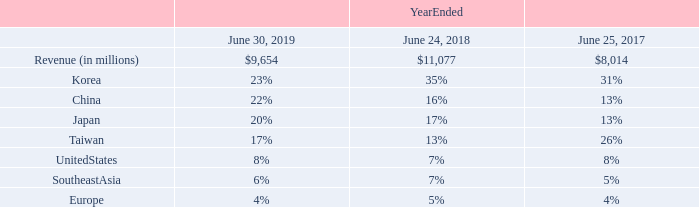Results of Operations
Revenue
Revenue decreased in fiscal year 2019 compared to fiscal year 2018, but increased compared to fiscal year 2017, primarily as a result of the volatility of semiconductor capital investments by our customers. The overall Asia region continued to account for a majority of our revenues as a substantial amount of the worldwide capacity investments for semiconductor manufacturing continued to occur in this region.
Our deferred revenue balance was $449 million as of June 30, 2019, compared to $994 million as of June 24, 2018. The deferred revenue at the end of June 2019 is recognized under Accounting Standard Codification (“ASC”) 606, while the same values as of June 2018 are recognized under ASC 605, which contributes to the change in value period over period. Our deferred revenue balance does not include shipments to customers in Japan, to whom title does not transfer until customer acceptance. Shipments to customers in Japan are classified as inventory at cost until the time of customer acceptance. The anticipated future revenue value from shipments to customers in Japan was approximately $78 million as of June 30, 2019, compared to $607 million as of June 24, 2018.
What is the deferred revenue at the end of June 2019 recognised under? Accounting standard codification (“asc”) 606. What is the percentage of Korea revenue in the total revenue on June 30, 2019? 23%. What is the percentage of China revenue in the total revenue on June 24, 2018? 16%. What is the percentage change in the total revenue from 2018 to 2019?
Answer scale should be: percent. (9,654-11,077)/11,077
Answer: -12.85. What is the percentage change in the deferred revenue balance from 2018 to 2019?
Answer scale should be: percent. (449-994)/994
Answer: -54.83. What is the percentage change in the anticipated future revenue value from shipments to customers in Japan from 2018 to 2019?
Answer scale should be: percent. (78-607)/607
Answer: -87.15. 